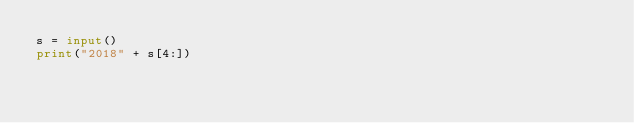<code> <loc_0><loc_0><loc_500><loc_500><_Python_>s = input()
print("2018" + s[4:])</code> 